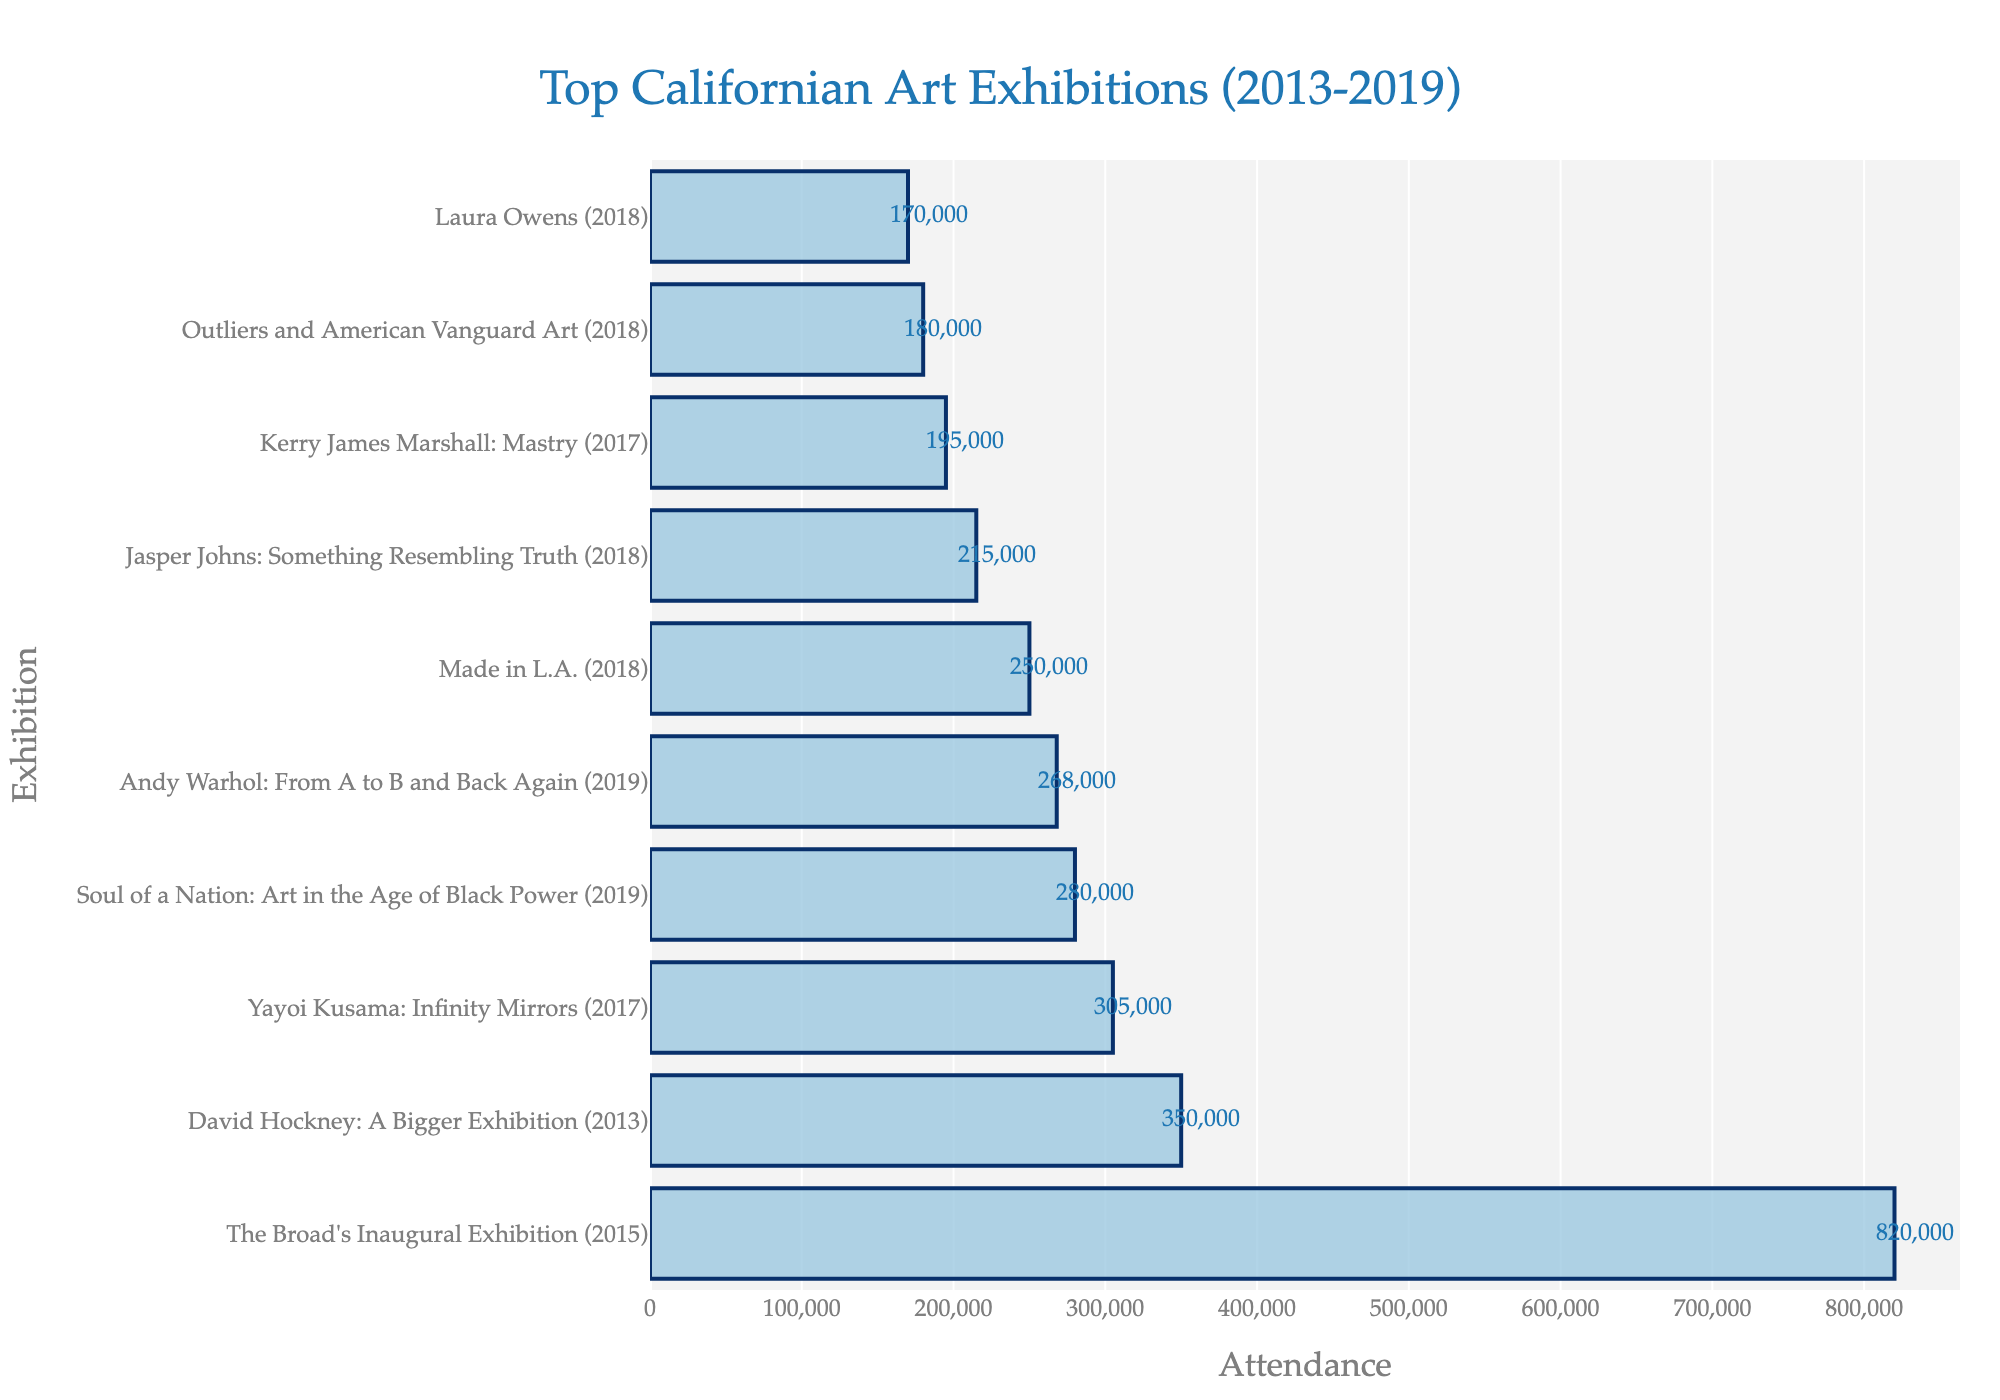Which exhibition has the highest attendance? The highest attendance can be identified by looking for the longest bar in the plot. The exhibition with the highest attendance is "The Broad's Inaugural Exhibition" with 820,000 attendees.
Answer: "The Broad's Inaugural Exhibition" What is the difference in attendance between "David Hockney: A Bigger Exhibition" and "Kerry James Marshall: Mastry"? To find the difference, identify the attendance of both exhibitions from the bars labeled "David Hockney: A Bigger Exhibition" (350,000) and "Kerry James Marshall: Mastry" (195,000) and subtract the smaller value from the larger one. 350,000 - 195,000 = 155,000.
Answer: 155,000 Which exhibition had a higher attendance, "Yayoi Kusama: Infinity Mirrors" or "Andy Warhol: From A to B and Back Again"? Compare the lengths of the bars for both exhibitions. The bar for "Yayoi Kusama: Infinity Mirrors" is longer, indicating higher attendance.
Answer: "Yayoi Kusama: Infinity Mirrors" What is the sum of the attendances for the exhibitions "Made in L.A." and "Laura Owens"? Identify the attendances for "Made in L.A." (250,000) and "Laura Owens" (170,000). Add the two values together: 250,000 + 170,000 = 420,000.
Answer: 420,000 What is the average attendance of the top 5 exhibitions? Identify the attendances of the top 5 exhibitions: "The Broad's Inaugural Exhibition" (820,000), "David Hockney: A Bigger Exhibition" (350,000), "Yayoi Kusama: Infinity Mirrors" (305,000), "Soul of a Nation: Art in the Age of Black Power" (280,000), and "Andy Warhol: From A to B and Back Again" (268,000). Sum these values and then divide by 5. (820,000 + 350,000 + 305,000 + 280,000 + 268,000) / 5 = 404,600.
Answer: 404,600 Which exhibition had the lowest attendance? Identify the shortest bar in the plot. The exhibition with the lowest attendance is "Laura Owens" with 170,000 attendees.
Answer: "Laura Owens" Is there a significant difference in attendance between the top exhibition and the second top exhibition? Compare the attendance of the top exhibition "The Broad's Inaugural Exhibition" (820,000) with the second top "David Hockney: A Bigger Exhibition" (350,000). The difference is significant: 820,000 - 350,000 = 470,000.
Answer: Yes What is the combined attendance of all exhibitions in 2018? Identify the 2018 exhibitions and their attendances: "Made in L.A." (250,000), "Jasper Johns: Something Resembling Truth" (215,000), "Outliers and American Vanguard Art" (180,000), and "Laura Owens" (170,000). Sum these values: 250,000 + 215,000 + 180,000 + 170,000 = 815,000.
Answer: 815,000 